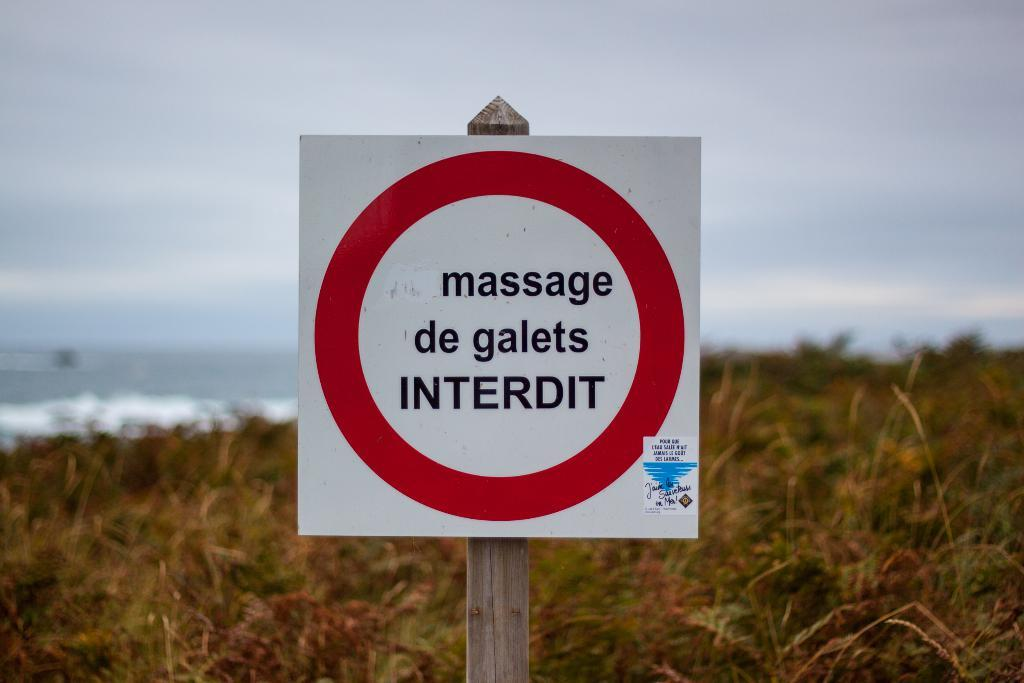What is on the wooden pole in the image? There is a signboard on a wooden pole in the image. What type of vegetation can be seen in the image? There are plants visible in the image. What natural feature is present in the image? There is a water body in the image. What is the condition of the sky in the image? The sky appears cloudy in the image. Can you hear the baby crying near the water body in the image? There is no baby or any sound mentioned in the image, so it is not possible to answer that question. 